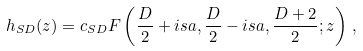Convert formula to latex. <formula><loc_0><loc_0><loc_500><loc_500>h _ { S D } ( z ) = c _ { S D } F \left ( \frac { D } { 2 } + i s a , \frac { D } { 2 } - i s a , \frac { D + 2 } { 2 } ; z \right ) \, ,</formula> 